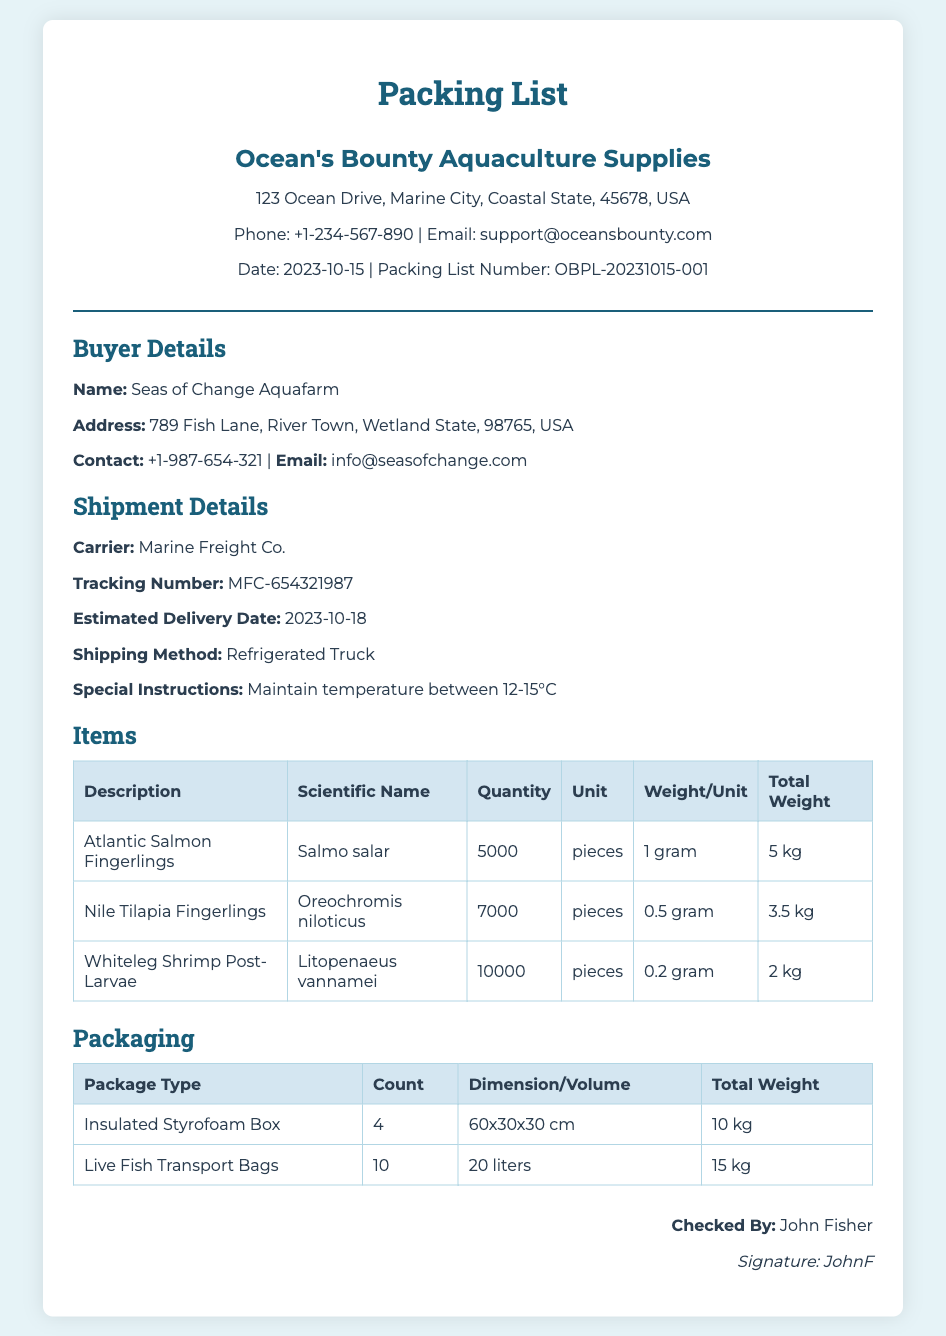What is the date of the packing list? The date of the packing list is listed in the document as 2023-10-15.
Answer: 2023-10-15 Who is the buyer of the fingerlings? The buyer details section of the document identifies the buyer as "Seas of Change Aquafarm."
Answer: Seas of Change Aquafarm What is the tracking number for the shipment? The tracking number is provided in the shipment details section as MFC-654321987.
Answer: MFC-654321987 How many Atlantic Salmon Fingerlings are included? The document specifies that there are 5000 Atlantic Salmon Fingerlings listed under items.
Answer: 5000 What is the total weight of the Whiteleg Shrimp Post-Larvae? The total weight for the Whiteleg Shrimp Post-Larvae is stated as 2 kg in the items table.
Answer: 2 kg How many live fish transport bags are there? The packaging section indicates that there are 10 live fish transport bags included in the shipment.
Answer: 10 What is the special instruction provided for the shipment? The special instruction for the shipment is to maintain temperature between 12-15°C.
Answer: Maintain temperature between 12-15°C What is the package type with the largest count? The package type with the largest count listed in the packaging table is the Insulated Styrofoam Box with a count of 4.
Answer: Insulated Styrofoam Box Who checked the packing list? The document indicates that the packing list was checked by John Fisher.
Answer: John Fisher 